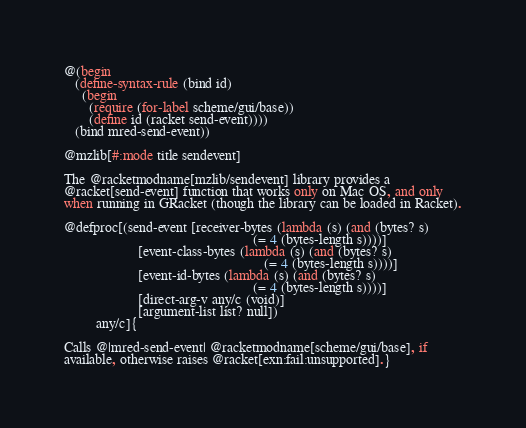<code> <loc_0><loc_0><loc_500><loc_500><_Racket_>
@(begin
   (define-syntax-rule (bind id)
     (begin
       (require (for-label scheme/gui/base))
       (define id (racket send-event))))
   (bind mred-send-event))

@mzlib[#:mode title sendevent]

The @racketmodname[mzlib/sendevent] library provides a
@racket[send-event] function that works only on Mac OS, and only
when running in GRacket (though the library can be loaded in Racket).

@defproc[(send-event [receiver-bytes (lambda (s) (and (bytes? s)
                                                      (= 4 (bytes-length s))))]
                     [event-class-bytes (lambda (s) (and (bytes? s)
                                                         (= 4 (bytes-length s))))]
                     [event-id-bytes (lambda (s) (and (bytes? s)
                                                      (= 4 (bytes-length s))))]
                     [direct-arg-v any/c (void)]
                     [argument-list list? null])
         any/c]{

Calls @|mred-send-event| @racketmodname[scheme/gui/base], if
available, otherwise raises @racket[exn:fail:unsupported].}
</code> 